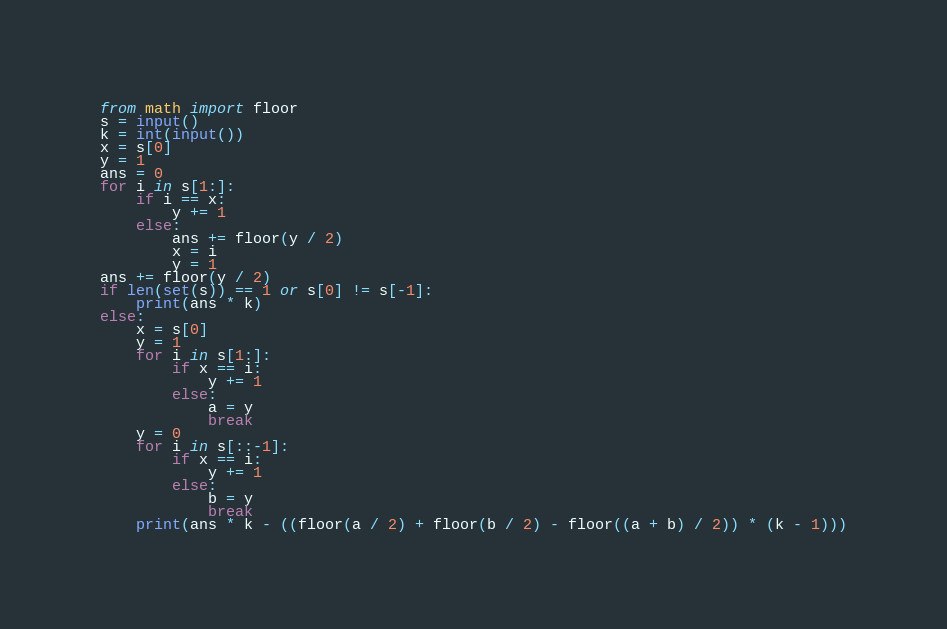<code> <loc_0><loc_0><loc_500><loc_500><_Python_>from math import floor
s = input()
k = int(input())
x = s[0]
y = 1
ans = 0
for i in s[1:]:
    if i == x:
        y += 1
    else:
        ans += floor(y / 2)
        x = i
        y = 1
ans += floor(y / 2)
if len(set(s)) == 1 or s[0] != s[-1]:
    print(ans * k)
else:
    x = s[0]
    y = 1
    for i in s[1:]:
        if x == i:
            y += 1
        else:
            a = y
            break
    y = 0
    for i in s[::-1]:
        if x == i:
            y += 1
        else:
            b = y
            break
    print(ans * k - ((floor(a / 2) + floor(b / 2) - floor((a + b) / 2)) * (k - 1)))</code> 